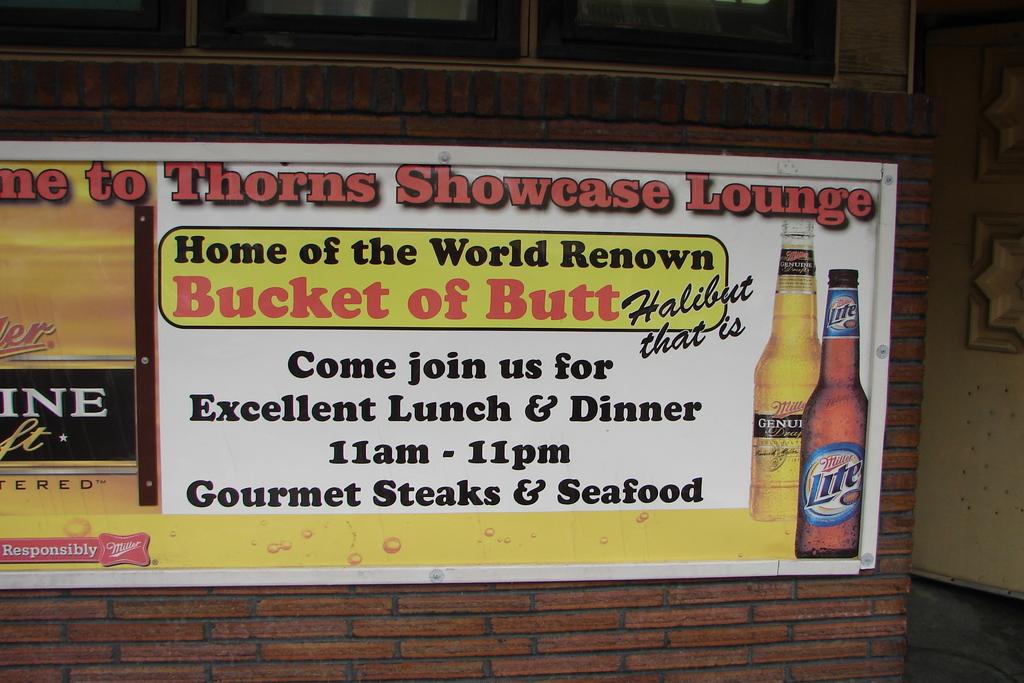What time does this establishment operate?
Offer a very short reply. 11am-11pm. 